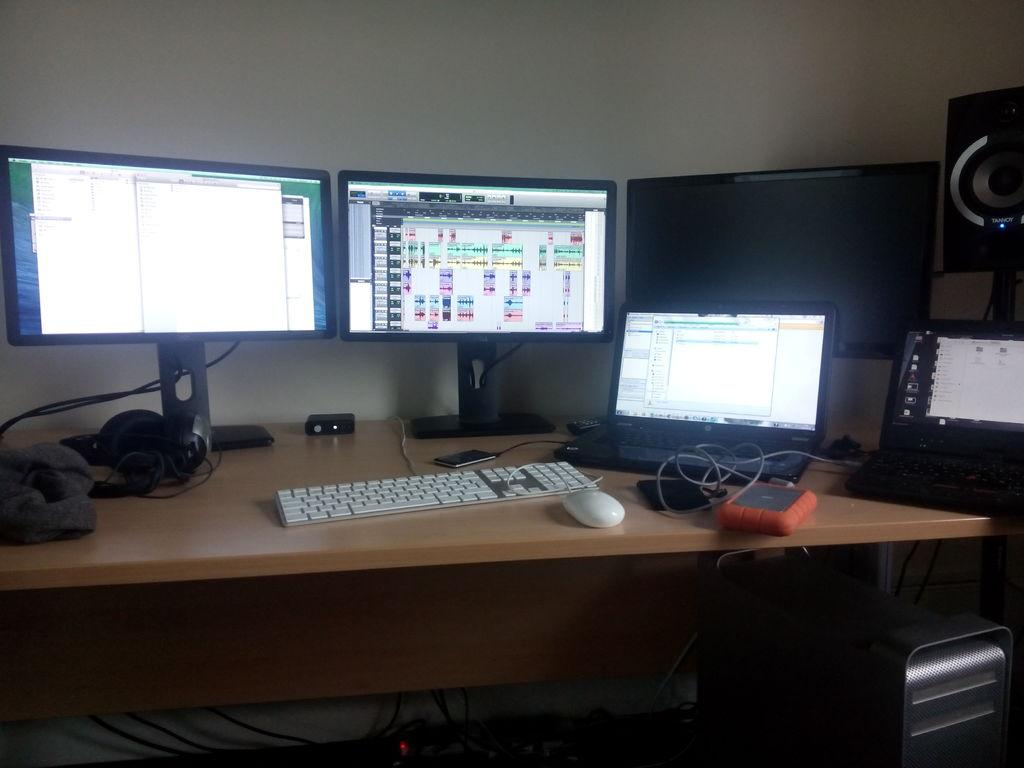What is located in the middle of the image? There is a table in the middle of the image. What electronic devices are on the table? PCs, keyboards, and mobile devices are on the table. Are there any wires visible on the table? Yes, wires are on the table. What is the color of the background wall in the image? The background wall is white in color. Where was the image taken? The image was taken inside a room. What type of seed is being planted in the image? There is no seed or planting activity present in the image. What nation is represented by the devices on the table? The devices on the table do not represent any specific nation. 